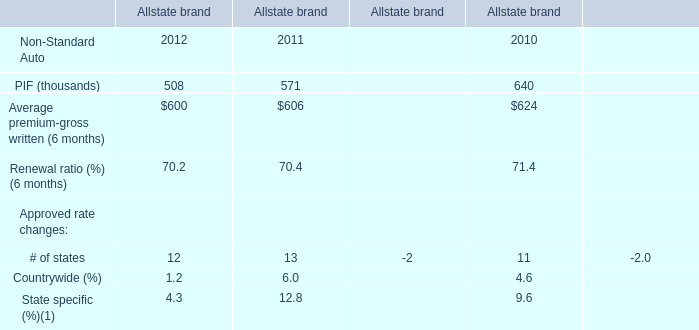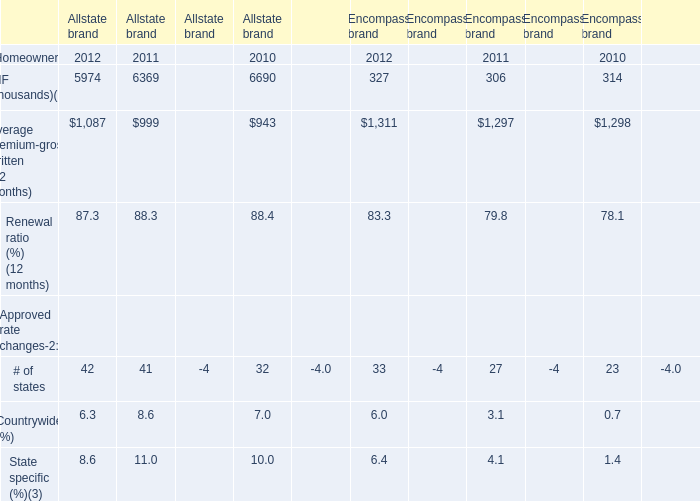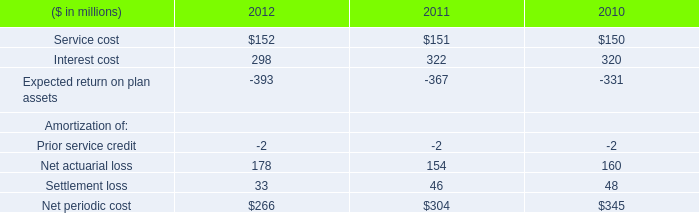What's the sum of PIF in 2012 and 2011 ? (in thousand) 
Computations: (508 + 571)
Answer: 1079.0. 